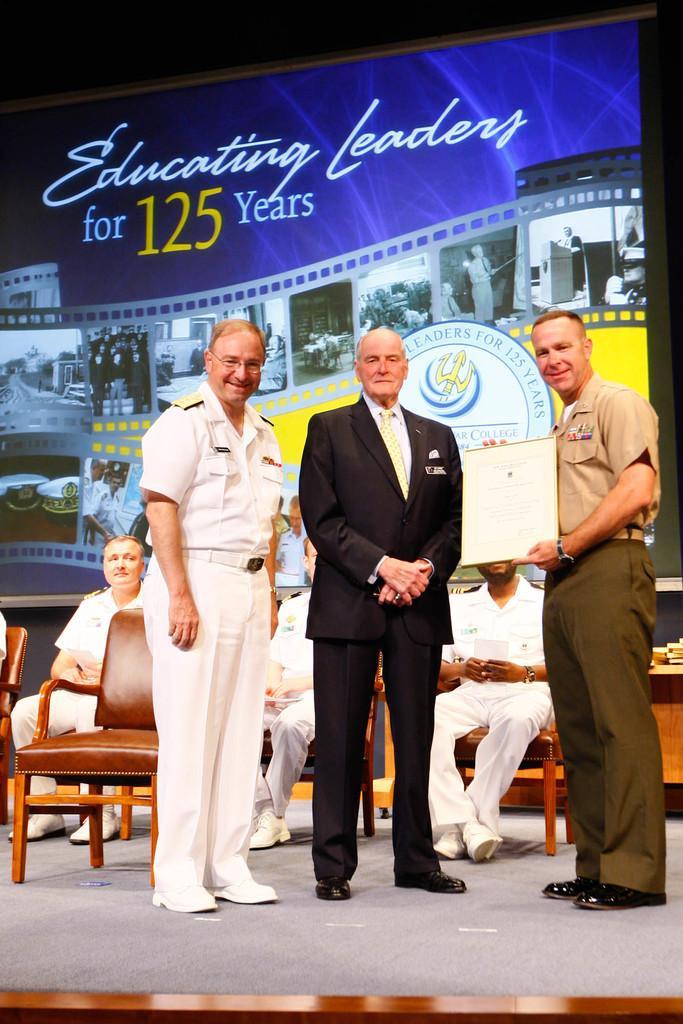Describe this image in one or two sentences. In this image we can see group of people standing on the stage. One person is wearing light brown shirt and holding a certificate in his hand. One person is wearing white uniform and spectacles. In the background we can see group of people sitting on chairs and a screen. 